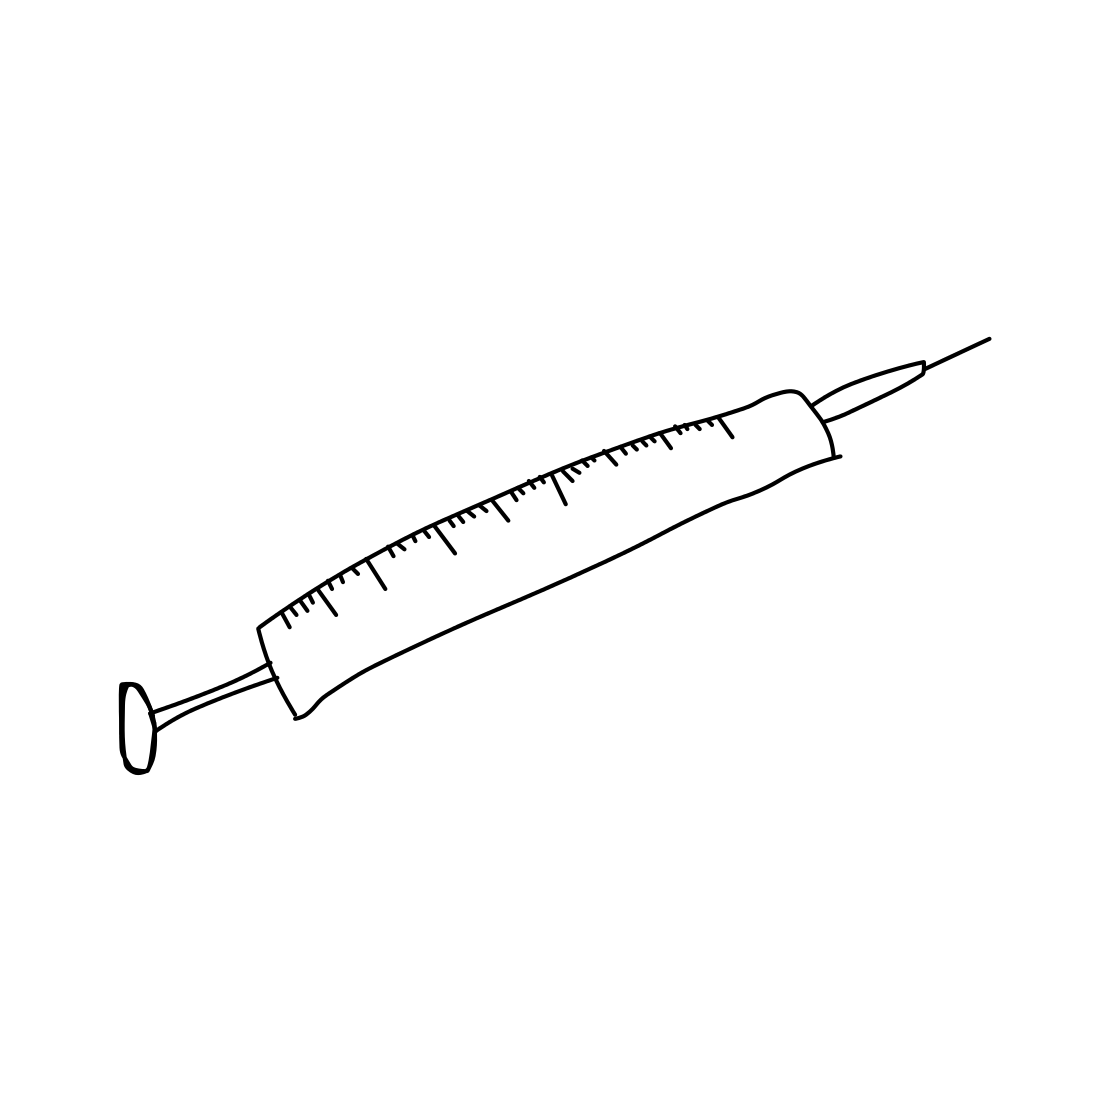In this task, you will identify whether the picture contains a living organism. The images given are black and white sketches drawn by human beings. If the picture depicts a living organism or part of a living organism, the output should be "Living". Otherwise, print "Non-Living" Based on the provided image, the object depicted is a syringe, which is an inanimate object used typically for medical purposes such as injecting substances into the body or extracting fluids from it. Since the image does not depict a living organism or any part of a living organism, but rather a man-made tool, the correct classification according to the task's criteria is "Non-Living". 